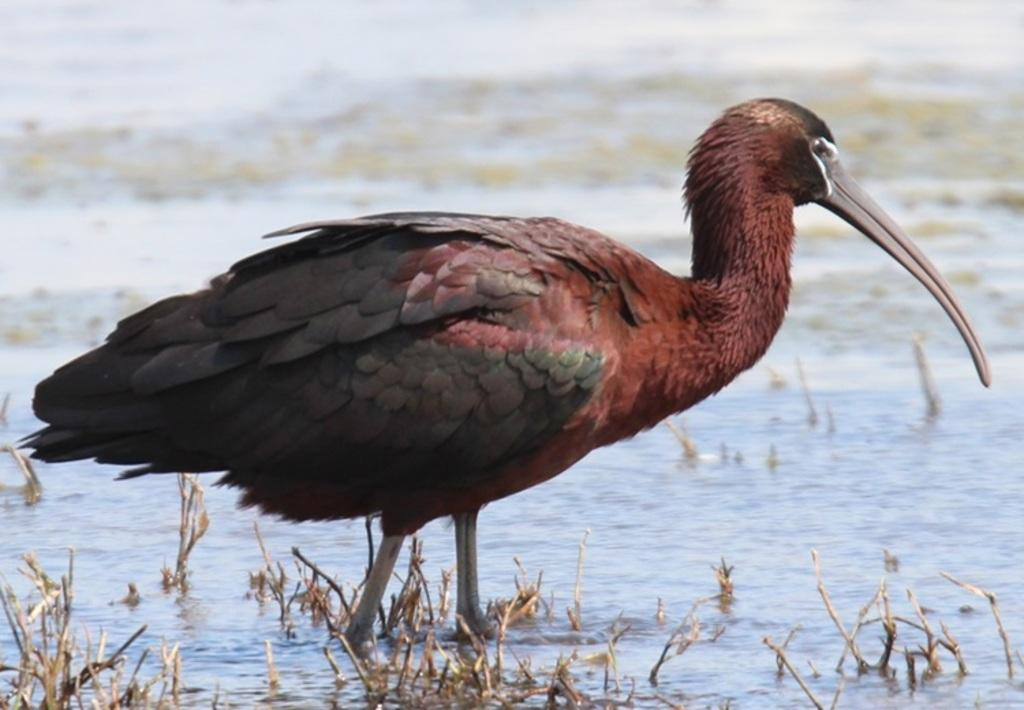What type of animal is in the image? There is a bird in the image. What colors can be seen on the bird? The bird is in black and maroon color. Where is the bird located in the image? The bird is standing in the water. What type of vegetation is present in the image? There are dry plants in the image. How would you describe the background of the image? The background of the image is slightly blurred. What type of silverware is visible in the image? There is no silverware present in the image; it features a bird standing in the water. What town can be seen in the background of the image? There is no town visible in the image; the background is slightly blurred and does not show any buildings or structures. 